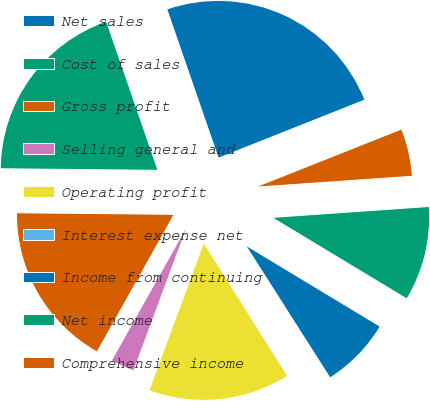Convert chart. <chart><loc_0><loc_0><loc_500><loc_500><pie_chart><fcel>Net sales<fcel>Cost of sales<fcel>Gross profit<fcel>Selling general and<fcel>Operating profit<fcel>Interest expense net<fcel>Income from continuing<fcel>Net income<fcel>Comprehensive income<nl><fcel>24.28%<fcel>19.54%<fcel>17.02%<fcel>2.49%<fcel>14.6%<fcel>0.07%<fcel>7.33%<fcel>9.75%<fcel>4.91%<nl></chart> 